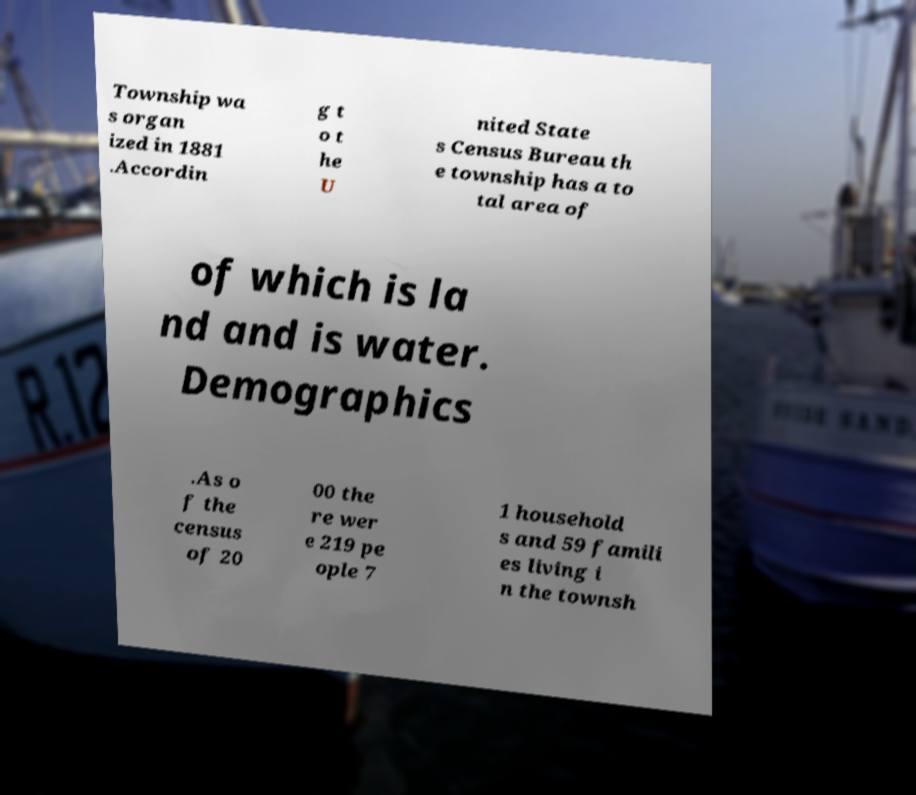Can you accurately transcribe the text from the provided image for me? Township wa s organ ized in 1881 .Accordin g t o t he U nited State s Census Bureau th e township has a to tal area of of which is la nd and is water. Demographics .As o f the census of 20 00 the re wer e 219 pe ople 7 1 household s and 59 famili es living i n the townsh 